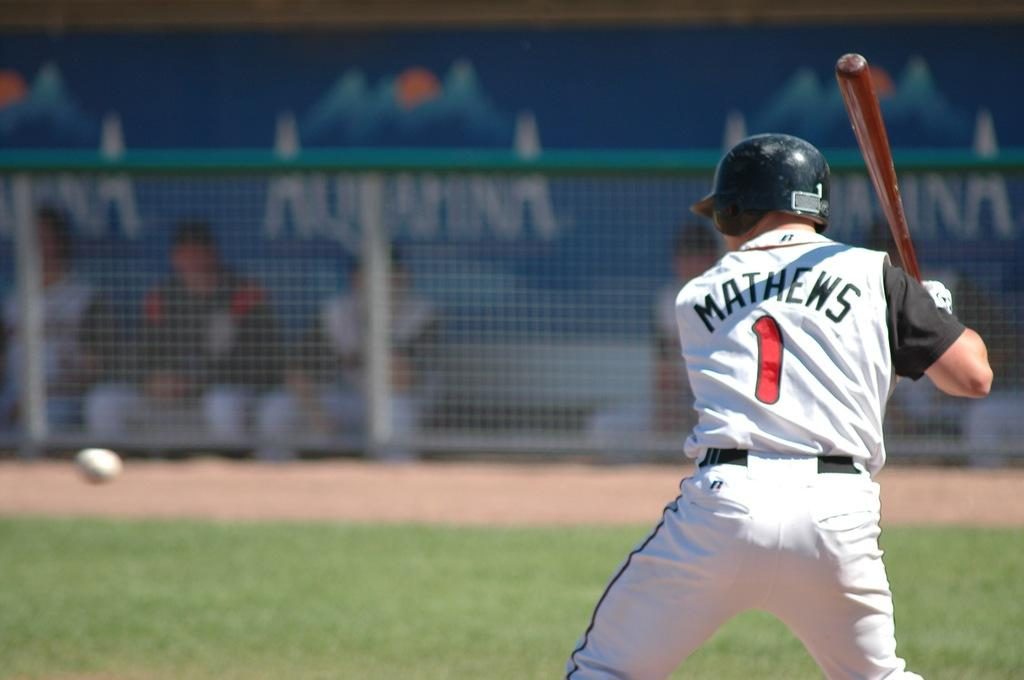<image>
Give a short and clear explanation of the subsequent image. The batter Matthews is ready for the pitch and in the background other players watch against an Aquafina advertisement. 